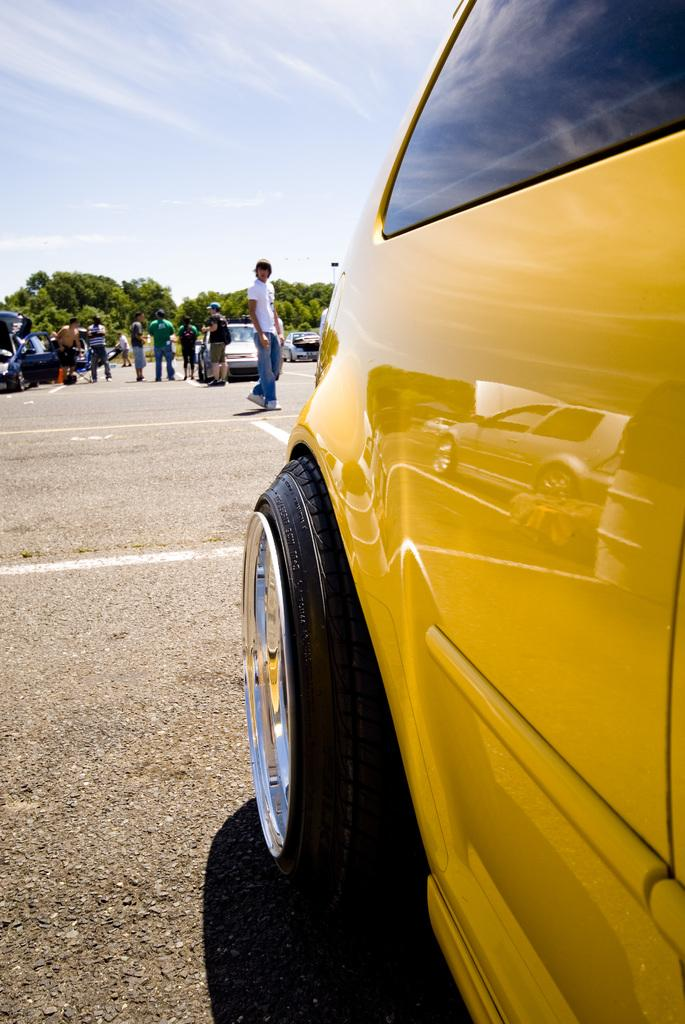What can be seen in the image that moves on roads? There are vehicles in the image that move on roads. What else can be seen on the road in the image? There are persons on the road in the image. What type of natural scenery is visible in the background of the image? There are trees in the background of the image. What is visible above the trees in the background? The sky is visible in the background of the image. How many clocks are hanging on the trees in the image? There are no clocks hanging on the trees in the image. What type of frame surrounds the image? The image does not have a frame; it is a digital representation. 